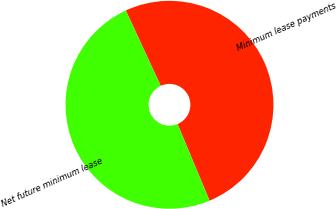<chart> <loc_0><loc_0><loc_500><loc_500><pie_chart><fcel>Minimum lease payments<fcel>Net future minimum lease<nl><fcel>50.61%<fcel>49.39%<nl></chart> 